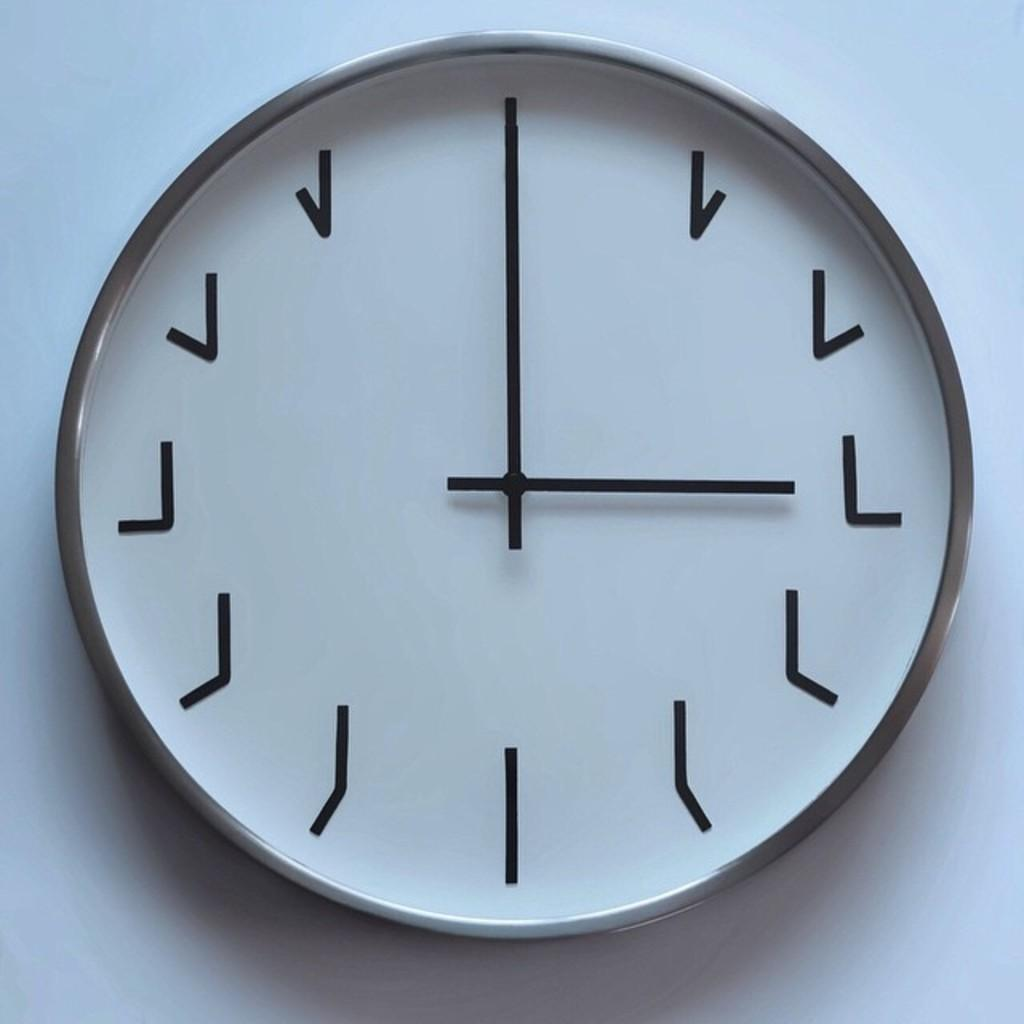What object is present in the image that displays time? There is a round wall clock in the image. What is the color of the surface on which the wall clock is placed? The wall clock is on a white surface. What is the rate of the hour hand's movement in the image? The image does not provide information about the rate of the hour hand's movement, as it only shows the wall clock's appearance. 